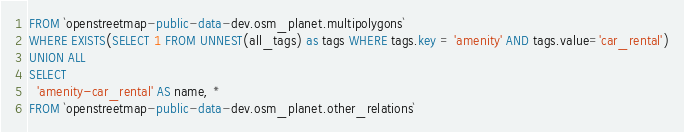Convert code to text. <code><loc_0><loc_0><loc_500><loc_500><_SQL_>FROM `openstreetmap-public-data-dev.osm_planet.multipolygons`
WHERE EXISTS(SELECT 1 FROM UNNEST(all_tags) as tags WHERE tags.key = 'amenity' AND tags.value='car_rental')
UNION ALL
SELECT
  'amenity-car_rental' AS name, *
FROM `openstreetmap-public-data-dev.osm_planet.other_relations`</code> 